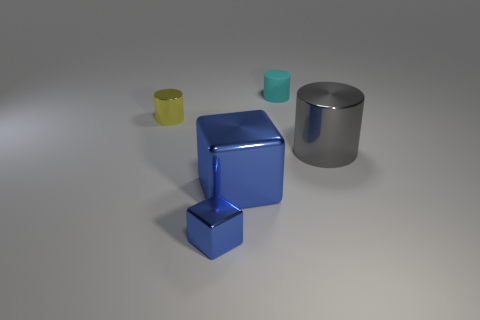Subtract all small cylinders. How many cylinders are left? 1 Add 4 small blue matte spheres. How many objects exist? 9 Subtract all brown cylinders. Subtract all cyan cubes. How many cylinders are left? 3 Subtract all cubes. How many objects are left? 3 Add 3 large gray objects. How many large gray objects exist? 4 Subtract 1 gray cylinders. How many objects are left? 4 Subtract all tiny gray cylinders. Subtract all yellow metal cylinders. How many objects are left? 4 Add 1 blue metal blocks. How many blue metal blocks are left? 3 